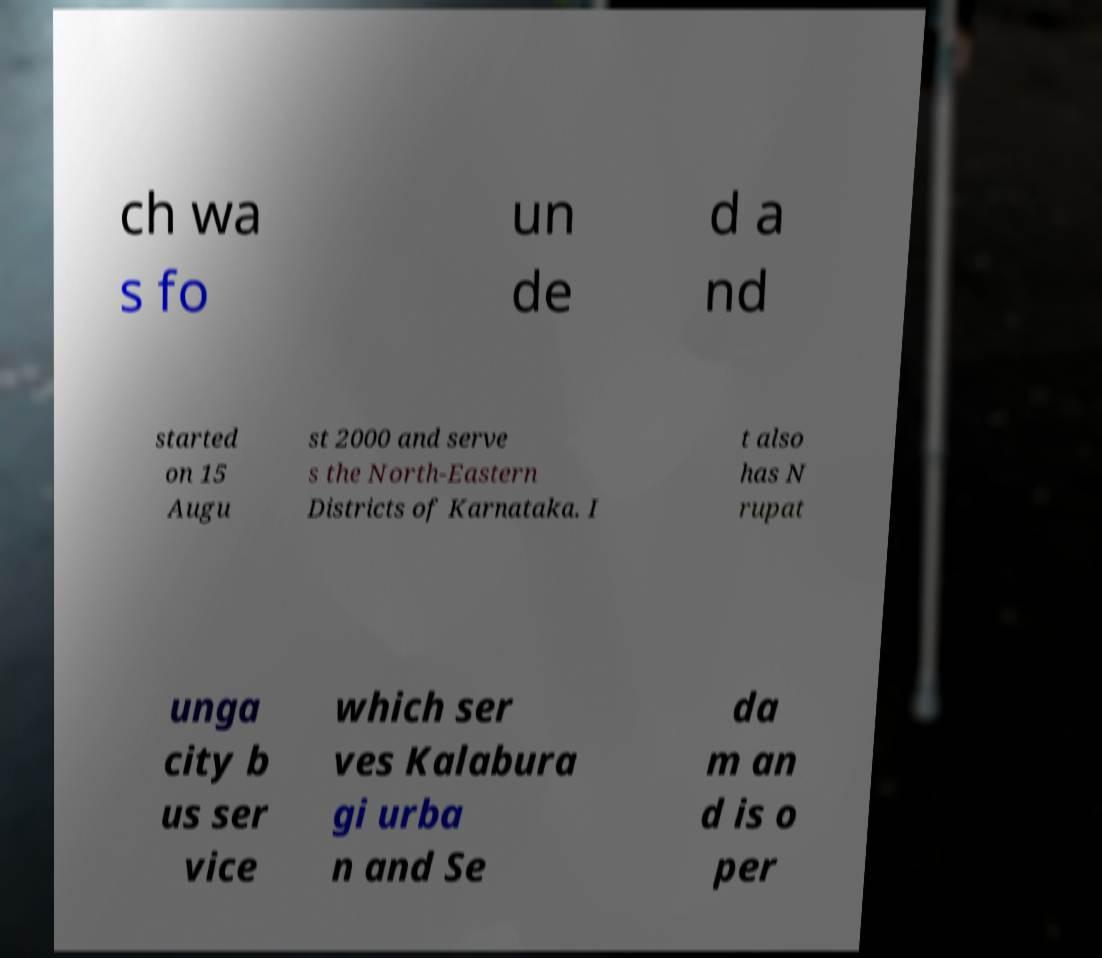Please read and relay the text visible in this image. What does it say? ch wa s fo un de d a nd started on 15 Augu st 2000 and serve s the North-Eastern Districts of Karnataka. I t also has N rupat unga city b us ser vice which ser ves Kalabura gi urba n and Se da m an d is o per 